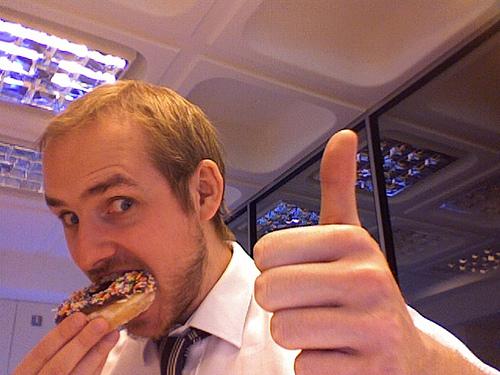What is he eating?
Short answer required. Donut. Is this person wearing a hat?
Short answer required. No. What is the man eating?
Write a very short answer. Donut. What color are his eyes?
Be succinct. Blue. What kind of food is this?
Write a very short answer. Donut. Is he enjoying the food?
Short answer required. Yes. 